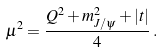<formula> <loc_0><loc_0><loc_500><loc_500>\mu ^ { 2 } = \frac { Q ^ { 2 } + m _ { J / \psi } ^ { 2 } + | t | } { 4 } \, .</formula> 